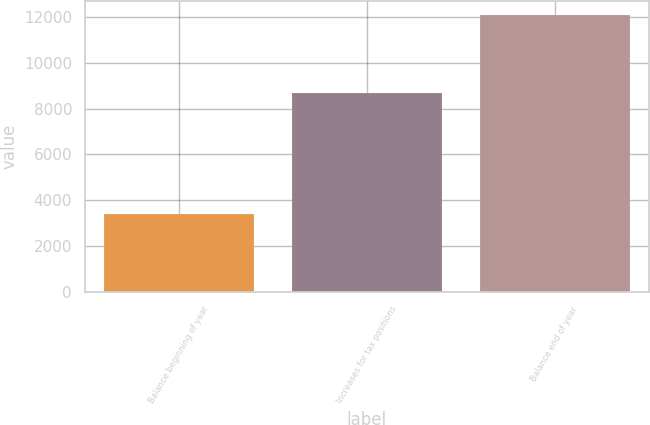Convert chart to OTSL. <chart><loc_0><loc_0><loc_500><loc_500><bar_chart><fcel>Balance beginning of year<fcel>Increases for tax positions<fcel>Balance end of year<nl><fcel>3387<fcel>8696<fcel>12083<nl></chart> 